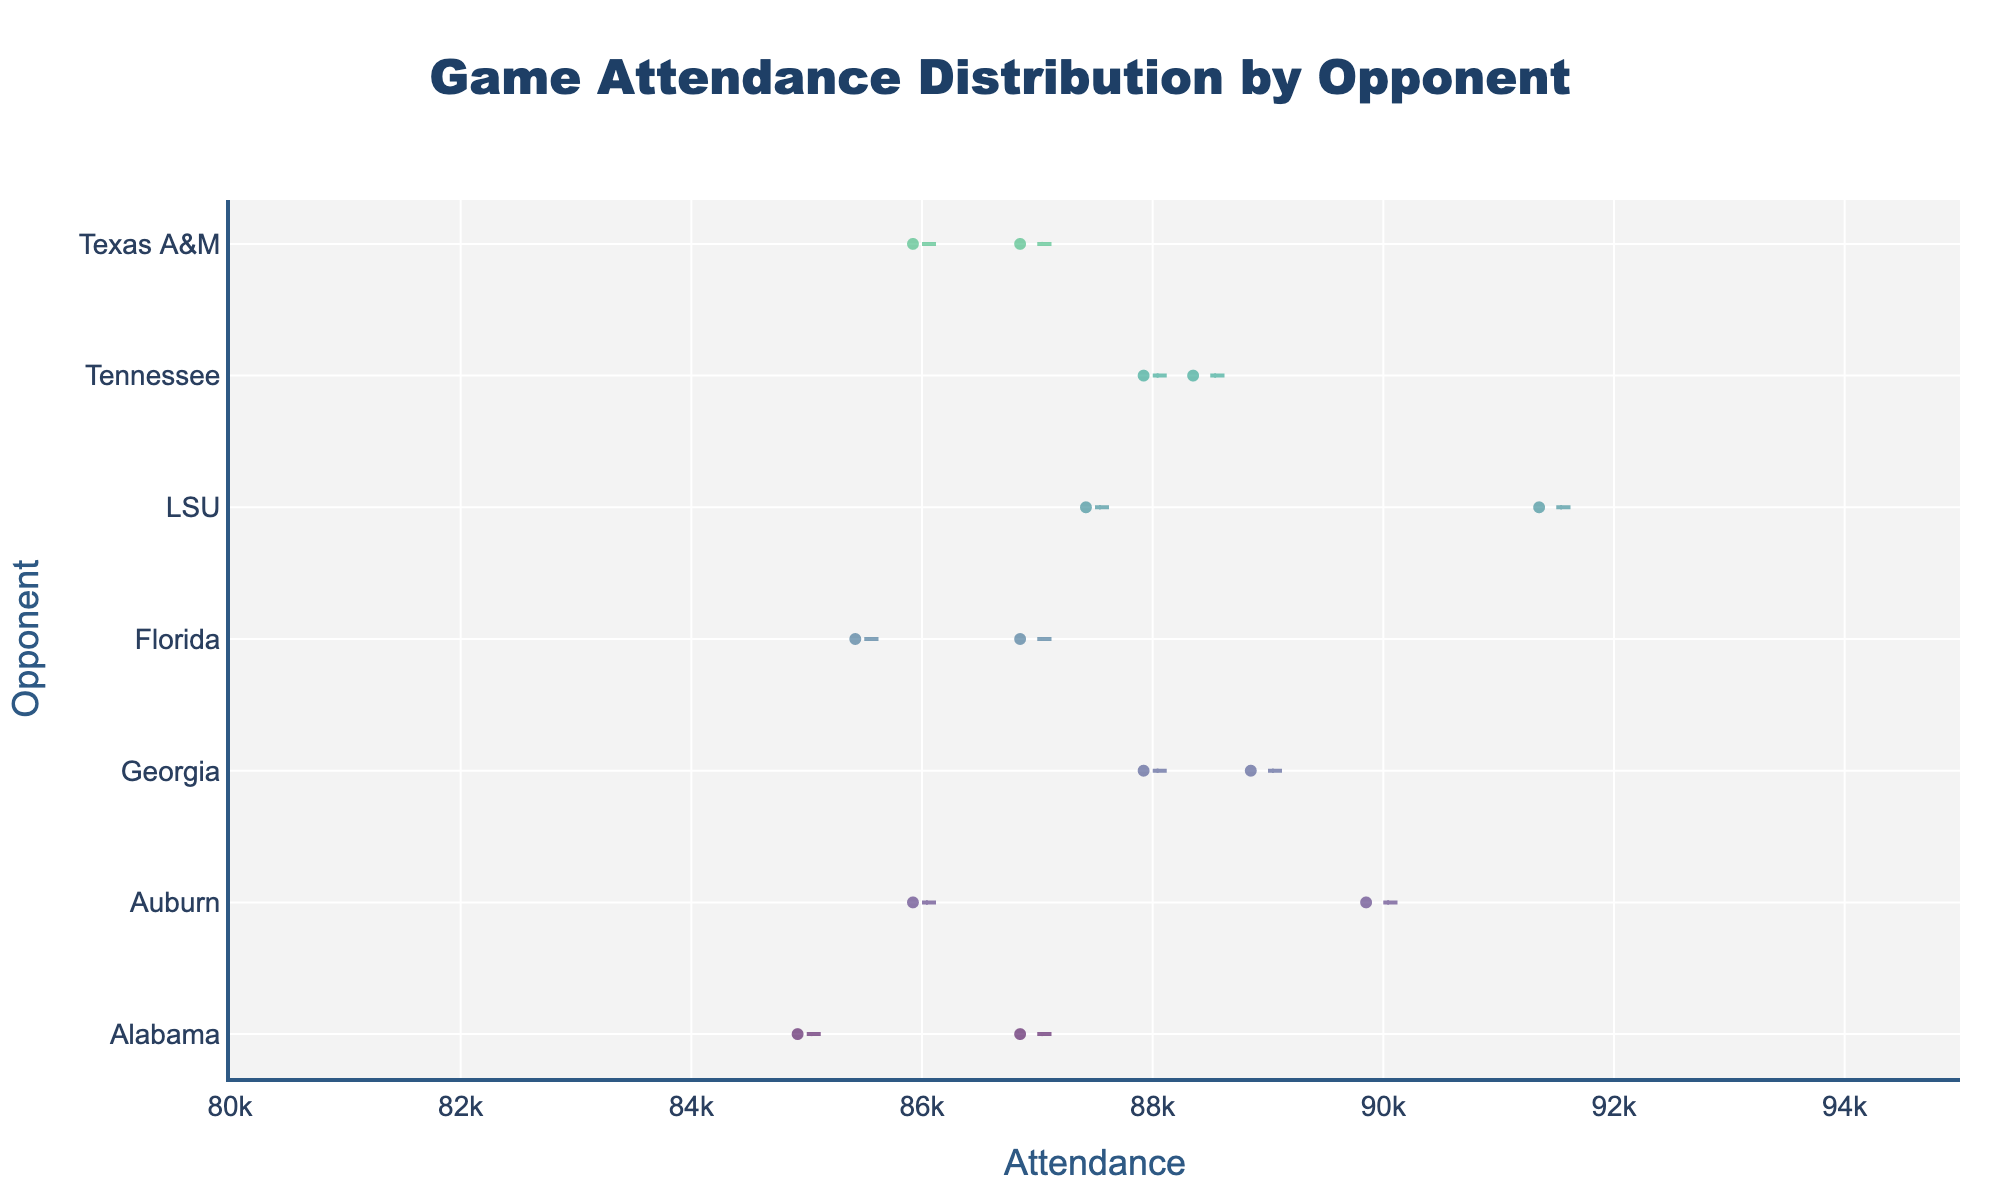What's the title of the chart? The title is located at the top of the figure and summarizes the entire chart.
Answer: Game Attendance Distribution by Opponent How many opponents are represented in the chart? The y-axis lists each opponent uniquely, which can be counted. There are 7 opponents: Alabama, Auburn, Georgia, Florida, LSU, Tennessee, and Texas A&M.
Answer: 7 Which opponent has the highest mean attendance? Each violin plot has a line representing the mean attendance, and LSU's mean attendance line is positioned the highest among all opponents.
Answer: LSU What is the range of attendance values displayed on the x-axis? The x-axis range can be observed directly, starting at 80,000 and ending at 95,000.
Answer: 80,000 to 95,000 How does the attendance distribution for Alabama compare to Auburn? By looking at the shape and spread of the violin plots for both Alabama and Auburn, we can see that Alabama's attendance values are slightly narrower and have lower ranges compared to Auburn.
Answer: Alabama has a narrower range and lower values What is the median attendance value for Georgia? Georgia's median attendance value is indicated by the thick horizontal line within its box plot, which falls around the 88,000 mark.
Answer: 88,000 Which opponent's games show the most variation in attendance? By examining the spread of each violin plot, LSU’s distribution appears the widest, indicating the most variation.
Answer: LSU Between Florida and Tennessee, which opponent has a more consistent attendance? Florida’s violin plot is narrower and more tightly clustered than Tennessee’s, showing more consistent attendance values.
Answer: Florida On average, do more people attend games against Alabama or Texas A&M? Comparing the means indicated by lines within the violin plots, Alabama’s mean attendance line is slightly higher than Texas A&M’s.
Answer: Alabama Which opponent has the most outliers in their attendance distribution? Observing the scattered points outside the main bulk of the violin shapes, Alabama has more scattered points than the others, indicating more outliers.
Answer: Alabama 